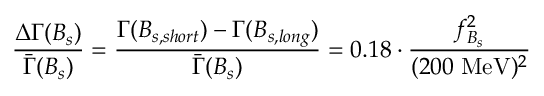<formula> <loc_0><loc_0><loc_500><loc_500>\frac { \Delta \Gamma ( B _ { s } ) } { \bar { \Gamma } ( B _ { s } ) } = \frac { \Gamma ( B _ { s , s h o r t } ) - \Gamma ( B _ { s , l o n g } ) } { \bar { \Gamma } ( B _ { s } ) } = 0 . 1 8 \cdot \frac { f _ { B _ { s } } ^ { 2 } } { ( 2 0 0 \, M e V ) ^ { 2 } }</formula> 